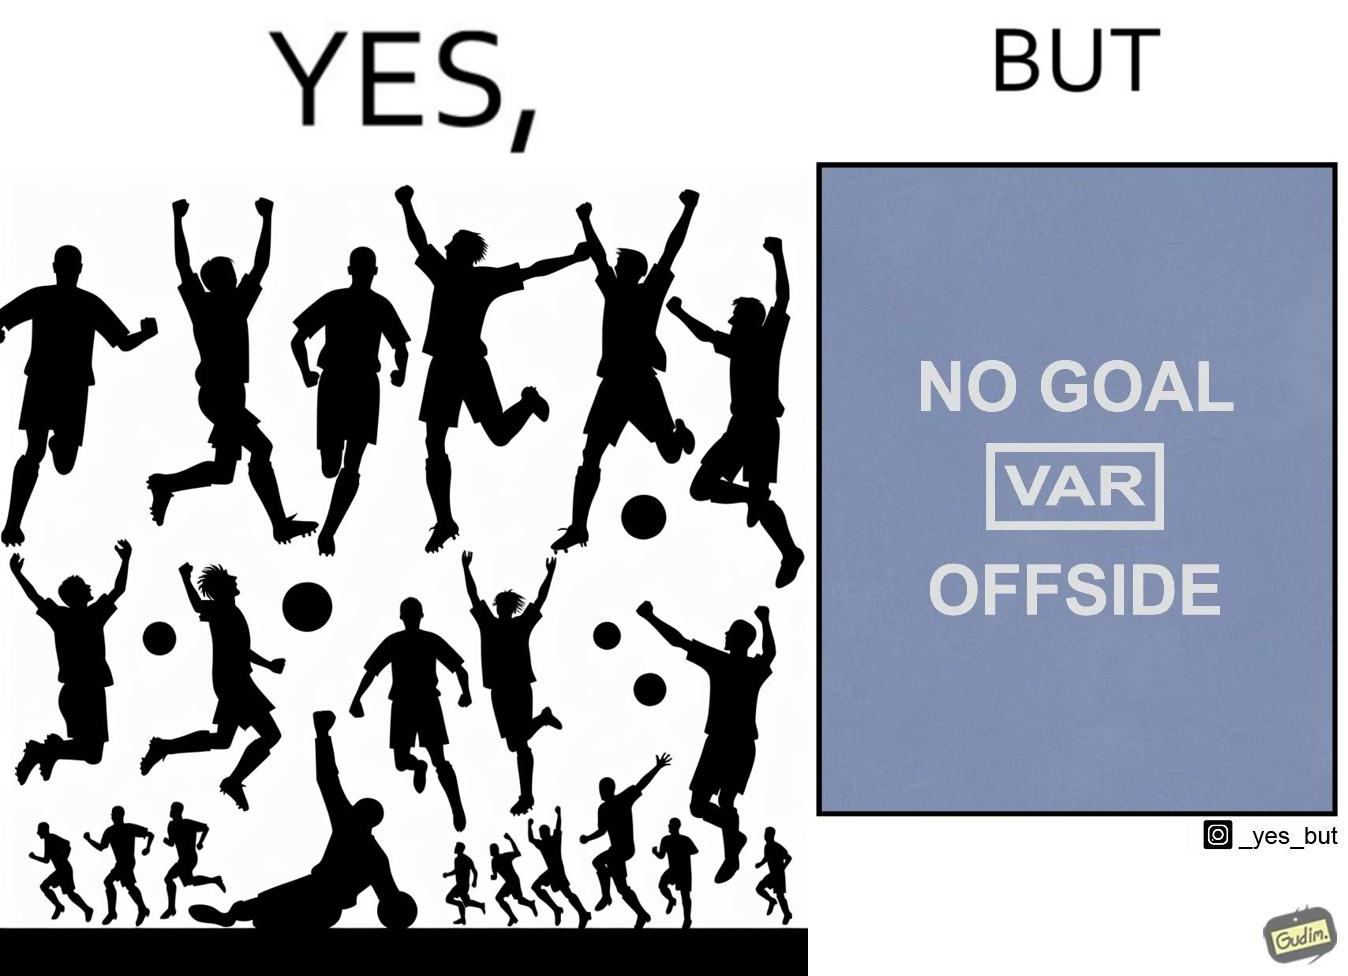Is this image satirical or non-satirical? Yes, this image is satirical. 